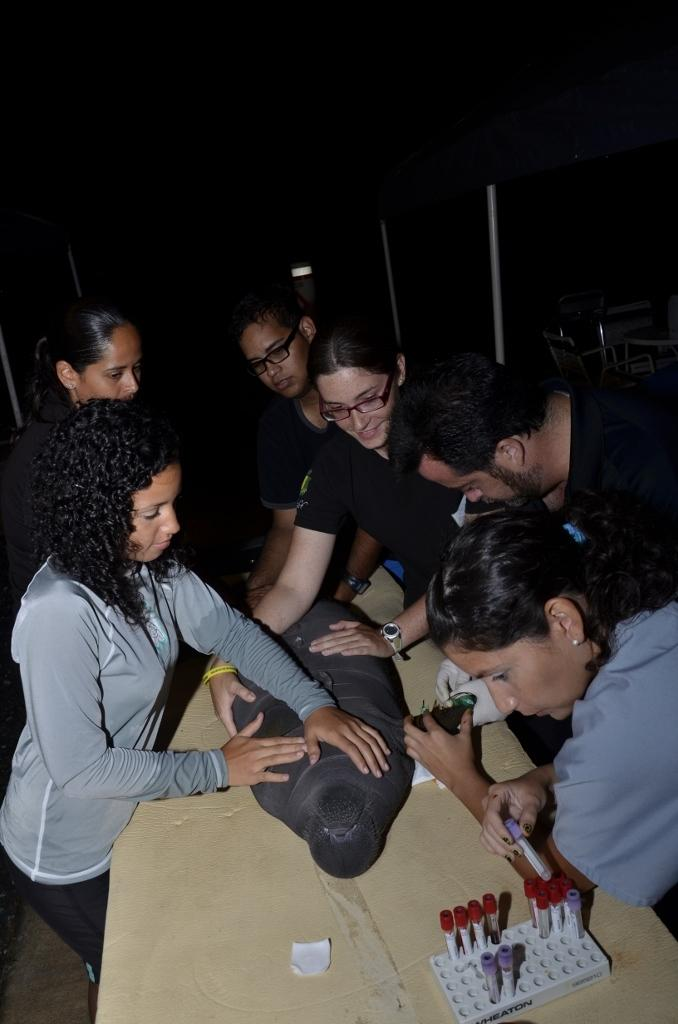How many people are in the image? There is a group of people in the image. What are the people in the image doing? The people are standing. Can you describe any objects in the image? There is an object on a table in the image. How does the group of people adjust their driving skills in the image? There is no driving or adjustment of driving skills present in the image; the people are simply standing. 